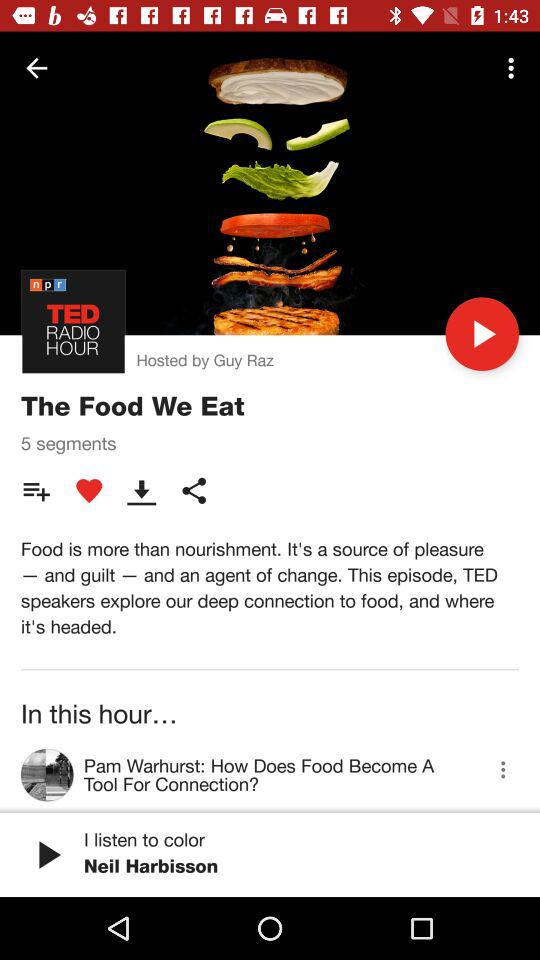How many segments are there? There are 5 segments. 